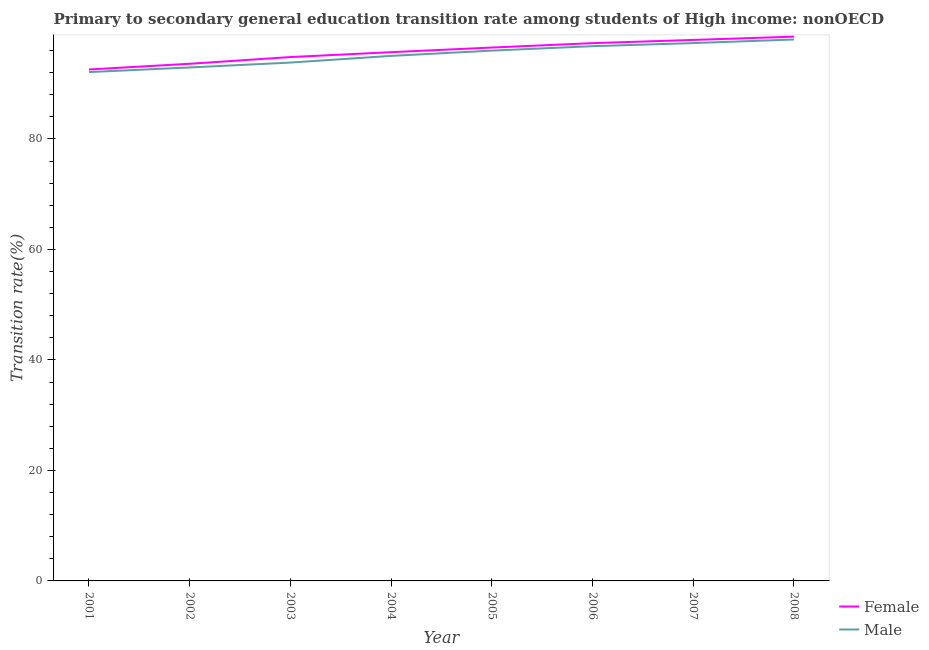Is the number of lines equal to the number of legend labels?
Your response must be concise. Yes. What is the transition rate among female students in 2008?
Offer a very short reply. 98.51. Across all years, what is the maximum transition rate among male students?
Your response must be concise. 98. Across all years, what is the minimum transition rate among female students?
Give a very brief answer. 92.57. In which year was the transition rate among male students maximum?
Offer a terse response. 2008. In which year was the transition rate among female students minimum?
Offer a terse response. 2001. What is the total transition rate among male students in the graph?
Your response must be concise. 761.99. What is the difference between the transition rate among male students in 2002 and that in 2006?
Your answer should be compact. -3.85. What is the difference between the transition rate among male students in 2003 and the transition rate among female students in 2008?
Offer a very short reply. -4.69. What is the average transition rate among male students per year?
Offer a terse response. 95.25. In the year 2008, what is the difference between the transition rate among male students and transition rate among female students?
Offer a very short reply. -0.51. What is the ratio of the transition rate among female students in 2006 to that in 2007?
Offer a terse response. 0.99. Is the difference between the transition rate among female students in 2001 and 2003 greater than the difference between the transition rate among male students in 2001 and 2003?
Provide a succinct answer. No. What is the difference between the highest and the second highest transition rate among female students?
Keep it short and to the point. 0.6. What is the difference between the highest and the lowest transition rate among female students?
Provide a succinct answer. 5.94. Is the sum of the transition rate among female students in 2005 and 2008 greater than the maximum transition rate among male students across all years?
Keep it short and to the point. Yes. Is the transition rate among male students strictly greater than the transition rate among female students over the years?
Give a very brief answer. No. How many years are there in the graph?
Offer a very short reply. 8. What is the difference between two consecutive major ticks on the Y-axis?
Make the answer very short. 20. How many legend labels are there?
Offer a very short reply. 2. How are the legend labels stacked?
Provide a succinct answer. Vertical. What is the title of the graph?
Provide a short and direct response. Primary to secondary general education transition rate among students of High income: nonOECD. What is the label or title of the X-axis?
Your response must be concise. Year. What is the label or title of the Y-axis?
Offer a very short reply. Transition rate(%). What is the Transition rate(%) in Female in 2001?
Provide a succinct answer. 92.57. What is the Transition rate(%) in Male in 2001?
Ensure brevity in your answer.  92.1. What is the Transition rate(%) of Female in 2002?
Ensure brevity in your answer.  93.6. What is the Transition rate(%) of Male in 2002?
Your response must be concise. 92.93. What is the Transition rate(%) in Female in 2003?
Offer a terse response. 94.82. What is the Transition rate(%) in Male in 2003?
Keep it short and to the point. 93.82. What is the Transition rate(%) of Female in 2004?
Offer a terse response. 95.7. What is the Transition rate(%) in Male in 2004?
Your answer should be compact. 95.03. What is the Transition rate(%) in Female in 2005?
Your answer should be very brief. 96.54. What is the Transition rate(%) of Male in 2005?
Give a very brief answer. 95.98. What is the Transition rate(%) in Female in 2006?
Offer a terse response. 97.33. What is the Transition rate(%) of Male in 2006?
Provide a succinct answer. 96.79. What is the Transition rate(%) in Female in 2007?
Ensure brevity in your answer.  97.91. What is the Transition rate(%) in Male in 2007?
Give a very brief answer. 97.34. What is the Transition rate(%) in Female in 2008?
Keep it short and to the point. 98.51. What is the Transition rate(%) in Male in 2008?
Your answer should be very brief. 98. Across all years, what is the maximum Transition rate(%) of Female?
Make the answer very short. 98.51. Across all years, what is the maximum Transition rate(%) of Male?
Ensure brevity in your answer.  98. Across all years, what is the minimum Transition rate(%) in Female?
Ensure brevity in your answer.  92.57. Across all years, what is the minimum Transition rate(%) of Male?
Keep it short and to the point. 92.1. What is the total Transition rate(%) of Female in the graph?
Provide a short and direct response. 766.98. What is the total Transition rate(%) in Male in the graph?
Ensure brevity in your answer.  761.99. What is the difference between the Transition rate(%) in Female in 2001 and that in 2002?
Your answer should be very brief. -1.03. What is the difference between the Transition rate(%) in Male in 2001 and that in 2002?
Keep it short and to the point. -0.84. What is the difference between the Transition rate(%) in Female in 2001 and that in 2003?
Ensure brevity in your answer.  -2.25. What is the difference between the Transition rate(%) in Male in 2001 and that in 2003?
Your answer should be very brief. -1.72. What is the difference between the Transition rate(%) of Female in 2001 and that in 2004?
Make the answer very short. -3.13. What is the difference between the Transition rate(%) of Male in 2001 and that in 2004?
Offer a very short reply. -2.93. What is the difference between the Transition rate(%) in Female in 2001 and that in 2005?
Offer a very short reply. -3.97. What is the difference between the Transition rate(%) in Male in 2001 and that in 2005?
Your answer should be compact. -3.89. What is the difference between the Transition rate(%) in Female in 2001 and that in 2006?
Offer a terse response. -4.76. What is the difference between the Transition rate(%) of Male in 2001 and that in 2006?
Provide a short and direct response. -4.69. What is the difference between the Transition rate(%) in Female in 2001 and that in 2007?
Offer a terse response. -5.34. What is the difference between the Transition rate(%) in Male in 2001 and that in 2007?
Offer a terse response. -5.25. What is the difference between the Transition rate(%) of Female in 2001 and that in 2008?
Provide a short and direct response. -5.94. What is the difference between the Transition rate(%) in Male in 2001 and that in 2008?
Your answer should be compact. -5.9. What is the difference between the Transition rate(%) of Female in 2002 and that in 2003?
Your answer should be very brief. -1.22. What is the difference between the Transition rate(%) of Male in 2002 and that in 2003?
Your answer should be very brief. -0.88. What is the difference between the Transition rate(%) of Female in 2002 and that in 2004?
Provide a succinct answer. -2.1. What is the difference between the Transition rate(%) of Male in 2002 and that in 2004?
Offer a terse response. -2.09. What is the difference between the Transition rate(%) of Female in 2002 and that in 2005?
Offer a very short reply. -2.94. What is the difference between the Transition rate(%) of Male in 2002 and that in 2005?
Provide a succinct answer. -3.05. What is the difference between the Transition rate(%) of Female in 2002 and that in 2006?
Your answer should be compact. -3.73. What is the difference between the Transition rate(%) in Male in 2002 and that in 2006?
Your answer should be compact. -3.85. What is the difference between the Transition rate(%) of Female in 2002 and that in 2007?
Give a very brief answer. -4.32. What is the difference between the Transition rate(%) in Male in 2002 and that in 2007?
Give a very brief answer. -4.41. What is the difference between the Transition rate(%) in Female in 2002 and that in 2008?
Keep it short and to the point. -4.91. What is the difference between the Transition rate(%) of Male in 2002 and that in 2008?
Offer a terse response. -5.06. What is the difference between the Transition rate(%) in Female in 2003 and that in 2004?
Offer a terse response. -0.88. What is the difference between the Transition rate(%) in Male in 2003 and that in 2004?
Your response must be concise. -1.21. What is the difference between the Transition rate(%) of Female in 2003 and that in 2005?
Ensure brevity in your answer.  -1.72. What is the difference between the Transition rate(%) of Male in 2003 and that in 2005?
Make the answer very short. -2.16. What is the difference between the Transition rate(%) of Female in 2003 and that in 2006?
Your response must be concise. -2.52. What is the difference between the Transition rate(%) in Male in 2003 and that in 2006?
Provide a succinct answer. -2.97. What is the difference between the Transition rate(%) of Female in 2003 and that in 2007?
Offer a very short reply. -3.1. What is the difference between the Transition rate(%) in Male in 2003 and that in 2007?
Your response must be concise. -3.52. What is the difference between the Transition rate(%) of Female in 2003 and that in 2008?
Your answer should be very brief. -3.69. What is the difference between the Transition rate(%) in Male in 2003 and that in 2008?
Your response must be concise. -4.18. What is the difference between the Transition rate(%) in Female in 2004 and that in 2005?
Make the answer very short. -0.84. What is the difference between the Transition rate(%) of Male in 2004 and that in 2005?
Give a very brief answer. -0.95. What is the difference between the Transition rate(%) of Female in 2004 and that in 2006?
Offer a very short reply. -1.63. What is the difference between the Transition rate(%) in Male in 2004 and that in 2006?
Your response must be concise. -1.76. What is the difference between the Transition rate(%) in Female in 2004 and that in 2007?
Your answer should be very brief. -2.22. What is the difference between the Transition rate(%) of Male in 2004 and that in 2007?
Offer a very short reply. -2.32. What is the difference between the Transition rate(%) in Female in 2004 and that in 2008?
Your response must be concise. -2.81. What is the difference between the Transition rate(%) of Male in 2004 and that in 2008?
Provide a short and direct response. -2.97. What is the difference between the Transition rate(%) of Female in 2005 and that in 2006?
Offer a very short reply. -0.8. What is the difference between the Transition rate(%) of Male in 2005 and that in 2006?
Provide a short and direct response. -0.8. What is the difference between the Transition rate(%) of Female in 2005 and that in 2007?
Keep it short and to the point. -1.38. What is the difference between the Transition rate(%) in Male in 2005 and that in 2007?
Offer a very short reply. -1.36. What is the difference between the Transition rate(%) of Female in 2005 and that in 2008?
Your answer should be compact. -1.97. What is the difference between the Transition rate(%) in Male in 2005 and that in 2008?
Your answer should be compact. -2.01. What is the difference between the Transition rate(%) of Female in 2006 and that in 2007?
Keep it short and to the point. -0.58. What is the difference between the Transition rate(%) of Male in 2006 and that in 2007?
Provide a succinct answer. -0.56. What is the difference between the Transition rate(%) in Female in 2006 and that in 2008?
Give a very brief answer. -1.18. What is the difference between the Transition rate(%) of Male in 2006 and that in 2008?
Keep it short and to the point. -1.21. What is the difference between the Transition rate(%) in Female in 2007 and that in 2008?
Ensure brevity in your answer.  -0.6. What is the difference between the Transition rate(%) in Male in 2007 and that in 2008?
Provide a succinct answer. -0.65. What is the difference between the Transition rate(%) of Female in 2001 and the Transition rate(%) of Male in 2002?
Offer a terse response. -0.36. What is the difference between the Transition rate(%) of Female in 2001 and the Transition rate(%) of Male in 2003?
Your response must be concise. -1.25. What is the difference between the Transition rate(%) in Female in 2001 and the Transition rate(%) in Male in 2004?
Your response must be concise. -2.46. What is the difference between the Transition rate(%) in Female in 2001 and the Transition rate(%) in Male in 2005?
Ensure brevity in your answer.  -3.41. What is the difference between the Transition rate(%) of Female in 2001 and the Transition rate(%) of Male in 2006?
Your answer should be very brief. -4.22. What is the difference between the Transition rate(%) in Female in 2001 and the Transition rate(%) in Male in 2007?
Your answer should be very brief. -4.77. What is the difference between the Transition rate(%) of Female in 2001 and the Transition rate(%) of Male in 2008?
Offer a very short reply. -5.43. What is the difference between the Transition rate(%) of Female in 2002 and the Transition rate(%) of Male in 2003?
Your answer should be very brief. -0.22. What is the difference between the Transition rate(%) in Female in 2002 and the Transition rate(%) in Male in 2004?
Your answer should be compact. -1.43. What is the difference between the Transition rate(%) of Female in 2002 and the Transition rate(%) of Male in 2005?
Provide a succinct answer. -2.38. What is the difference between the Transition rate(%) of Female in 2002 and the Transition rate(%) of Male in 2006?
Your response must be concise. -3.19. What is the difference between the Transition rate(%) in Female in 2002 and the Transition rate(%) in Male in 2007?
Offer a terse response. -3.75. What is the difference between the Transition rate(%) in Female in 2002 and the Transition rate(%) in Male in 2008?
Keep it short and to the point. -4.4. What is the difference between the Transition rate(%) of Female in 2003 and the Transition rate(%) of Male in 2004?
Your answer should be compact. -0.21. What is the difference between the Transition rate(%) of Female in 2003 and the Transition rate(%) of Male in 2005?
Give a very brief answer. -1.17. What is the difference between the Transition rate(%) of Female in 2003 and the Transition rate(%) of Male in 2006?
Your response must be concise. -1.97. What is the difference between the Transition rate(%) of Female in 2003 and the Transition rate(%) of Male in 2007?
Provide a succinct answer. -2.53. What is the difference between the Transition rate(%) of Female in 2003 and the Transition rate(%) of Male in 2008?
Provide a short and direct response. -3.18. What is the difference between the Transition rate(%) in Female in 2004 and the Transition rate(%) in Male in 2005?
Give a very brief answer. -0.28. What is the difference between the Transition rate(%) in Female in 2004 and the Transition rate(%) in Male in 2006?
Keep it short and to the point. -1.09. What is the difference between the Transition rate(%) in Female in 2004 and the Transition rate(%) in Male in 2007?
Your answer should be very brief. -1.65. What is the difference between the Transition rate(%) of Female in 2004 and the Transition rate(%) of Male in 2008?
Your response must be concise. -2.3. What is the difference between the Transition rate(%) of Female in 2005 and the Transition rate(%) of Male in 2006?
Your answer should be compact. -0.25. What is the difference between the Transition rate(%) of Female in 2005 and the Transition rate(%) of Male in 2007?
Keep it short and to the point. -0.81. What is the difference between the Transition rate(%) in Female in 2005 and the Transition rate(%) in Male in 2008?
Keep it short and to the point. -1.46. What is the difference between the Transition rate(%) in Female in 2006 and the Transition rate(%) in Male in 2007?
Your response must be concise. -0.01. What is the difference between the Transition rate(%) of Female in 2006 and the Transition rate(%) of Male in 2008?
Provide a short and direct response. -0.66. What is the difference between the Transition rate(%) in Female in 2007 and the Transition rate(%) in Male in 2008?
Make the answer very short. -0.08. What is the average Transition rate(%) of Female per year?
Give a very brief answer. 95.87. What is the average Transition rate(%) of Male per year?
Ensure brevity in your answer.  95.25. In the year 2001, what is the difference between the Transition rate(%) of Female and Transition rate(%) of Male?
Your response must be concise. 0.47. In the year 2002, what is the difference between the Transition rate(%) in Female and Transition rate(%) in Male?
Ensure brevity in your answer.  0.66. In the year 2003, what is the difference between the Transition rate(%) of Female and Transition rate(%) of Male?
Provide a succinct answer. 1. In the year 2004, what is the difference between the Transition rate(%) of Female and Transition rate(%) of Male?
Ensure brevity in your answer.  0.67. In the year 2005, what is the difference between the Transition rate(%) of Female and Transition rate(%) of Male?
Give a very brief answer. 0.55. In the year 2006, what is the difference between the Transition rate(%) of Female and Transition rate(%) of Male?
Keep it short and to the point. 0.55. In the year 2007, what is the difference between the Transition rate(%) in Female and Transition rate(%) in Male?
Your answer should be compact. 0.57. In the year 2008, what is the difference between the Transition rate(%) in Female and Transition rate(%) in Male?
Make the answer very short. 0.51. What is the ratio of the Transition rate(%) of Female in 2001 to that in 2003?
Give a very brief answer. 0.98. What is the ratio of the Transition rate(%) of Male in 2001 to that in 2003?
Keep it short and to the point. 0.98. What is the ratio of the Transition rate(%) in Female in 2001 to that in 2004?
Provide a succinct answer. 0.97. What is the ratio of the Transition rate(%) in Male in 2001 to that in 2004?
Make the answer very short. 0.97. What is the ratio of the Transition rate(%) in Female in 2001 to that in 2005?
Offer a very short reply. 0.96. What is the ratio of the Transition rate(%) in Male in 2001 to that in 2005?
Give a very brief answer. 0.96. What is the ratio of the Transition rate(%) in Female in 2001 to that in 2006?
Offer a very short reply. 0.95. What is the ratio of the Transition rate(%) of Male in 2001 to that in 2006?
Offer a terse response. 0.95. What is the ratio of the Transition rate(%) of Female in 2001 to that in 2007?
Keep it short and to the point. 0.95. What is the ratio of the Transition rate(%) of Male in 2001 to that in 2007?
Make the answer very short. 0.95. What is the ratio of the Transition rate(%) in Female in 2001 to that in 2008?
Your answer should be compact. 0.94. What is the ratio of the Transition rate(%) in Male in 2001 to that in 2008?
Provide a short and direct response. 0.94. What is the ratio of the Transition rate(%) in Female in 2002 to that in 2003?
Your answer should be very brief. 0.99. What is the ratio of the Transition rate(%) of Male in 2002 to that in 2003?
Give a very brief answer. 0.99. What is the ratio of the Transition rate(%) of Female in 2002 to that in 2004?
Make the answer very short. 0.98. What is the ratio of the Transition rate(%) in Male in 2002 to that in 2004?
Your answer should be compact. 0.98. What is the ratio of the Transition rate(%) in Female in 2002 to that in 2005?
Provide a short and direct response. 0.97. What is the ratio of the Transition rate(%) of Male in 2002 to that in 2005?
Provide a short and direct response. 0.97. What is the ratio of the Transition rate(%) of Female in 2002 to that in 2006?
Offer a very short reply. 0.96. What is the ratio of the Transition rate(%) in Male in 2002 to that in 2006?
Ensure brevity in your answer.  0.96. What is the ratio of the Transition rate(%) in Female in 2002 to that in 2007?
Your answer should be very brief. 0.96. What is the ratio of the Transition rate(%) of Male in 2002 to that in 2007?
Make the answer very short. 0.95. What is the ratio of the Transition rate(%) in Female in 2002 to that in 2008?
Ensure brevity in your answer.  0.95. What is the ratio of the Transition rate(%) in Male in 2002 to that in 2008?
Ensure brevity in your answer.  0.95. What is the ratio of the Transition rate(%) of Female in 2003 to that in 2004?
Make the answer very short. 0.99. What is the ratio of the Transition rate(%) of Male in 2003 to that in 2004?
Your response must be concise. 0.99. What is the ratio of the Transition rate(%) in Female in 2003 to that in 2005?
Your answer should be compact. 0.98. What is the ratio of the Transition rate(%) in Male in 2003 to that in 2005?
Make the answer very short. 0.98. What is the ratio of the Transition rate(%) in Female in 2003 to that in 2006?
Offer a very short reply. 0.97. What is the ratio of the Transition rate(%) of Male in 2003 to that in 2006?
Your answer should be compact. 0.97. What is the ratio of the Transition rate(%) in Female in 2003 to that in 2007?
Your answer should be compact. 0.97. What is the ratio of the Transition rate(%) of Male in 2003 to that in 2007?
Give a very brief answer. 0.96. What is the ratio of the Transition rate(%) of Female in 2003 to that in 2008?
Your response must be concise. 0.96. What is the ratio of the Transition rate(%) in Male in 2003 to that in 2008?
Provide a succinct answer. 0.96. What is the ratio of the Transition rate(%) in Female in 2004 to that in 2005?
Ensure brevity in your answer.  0.99. What is the ratio of the Transition rate(%) in Female in 2004 to that in 2006?
Provide a succinct answer. 0.98. What is the ratio of the Transition rate(%) of Male in 2004 to that in 2006?
Provide a succinct answer. 0.98. What is the ratio of the Transition rate(%) of Female in 2004 to that in 2007?
Offer a very short reply. 0.98. What is the ratio of the Transition rate(%) of Male in 2004 to that in 2007?
Your answer should be very brief. 0.98. What is the ratio of the Transition rate(%) of Female in 2004 to that in 2008?
Make the answer very short. 0.97. What is the ratio of the Transition rate(%) in Male in 2004 to that in 2008?
Provide a succinct answer. 0.97. What is the ratio of the Transition rate(%) in Male in 2005 to that in 2006?
Give a very brief answer. 0.99. What is the ratio of the Transition rate(%) in Female in 2005 to that in 2007?
Your answer should be very brief. 0.99. What is the ratio of the Transition rate(%) of Female in 2005 to that in 2008?
Keep it short and to the point. 0.98. What is the ratio of the Transition rate(%) of Male in 2005 to that in 2008?
Offer a terse response. 0.98. What is the ratio of the Transition rate(%) of Male in 2006 to that in 2007?
Keep it short and to the point. 0.99. What is the ratio of the Transition rate(%) in Female in 2006 to that in 2008?
Make the answer very short. 0.99. What is the ratio of the Transition rate(%) in Male in 2006 to that in 2008?
Offer a terse response. 0.99. What is the ratio of the Transition rate(%) in Female in 2007 to that in 2008?
Your answer should be very brief. 0.99. What is the difference between the highest and the second highest Transition rate(%) of Female?
Your response must be concise. 0.6. What is the difference between the highest and the second highest Transition rate(%) of Male?
Keep it short and to the point. 0.65. What is the difference between the highest and the lowest Transition rate(%) of Female?
Make the answer very short. 5.94. What is the difference between the highest and the lowest Transition rate(%) of Male?
Give a very brief answer. 5.9. 